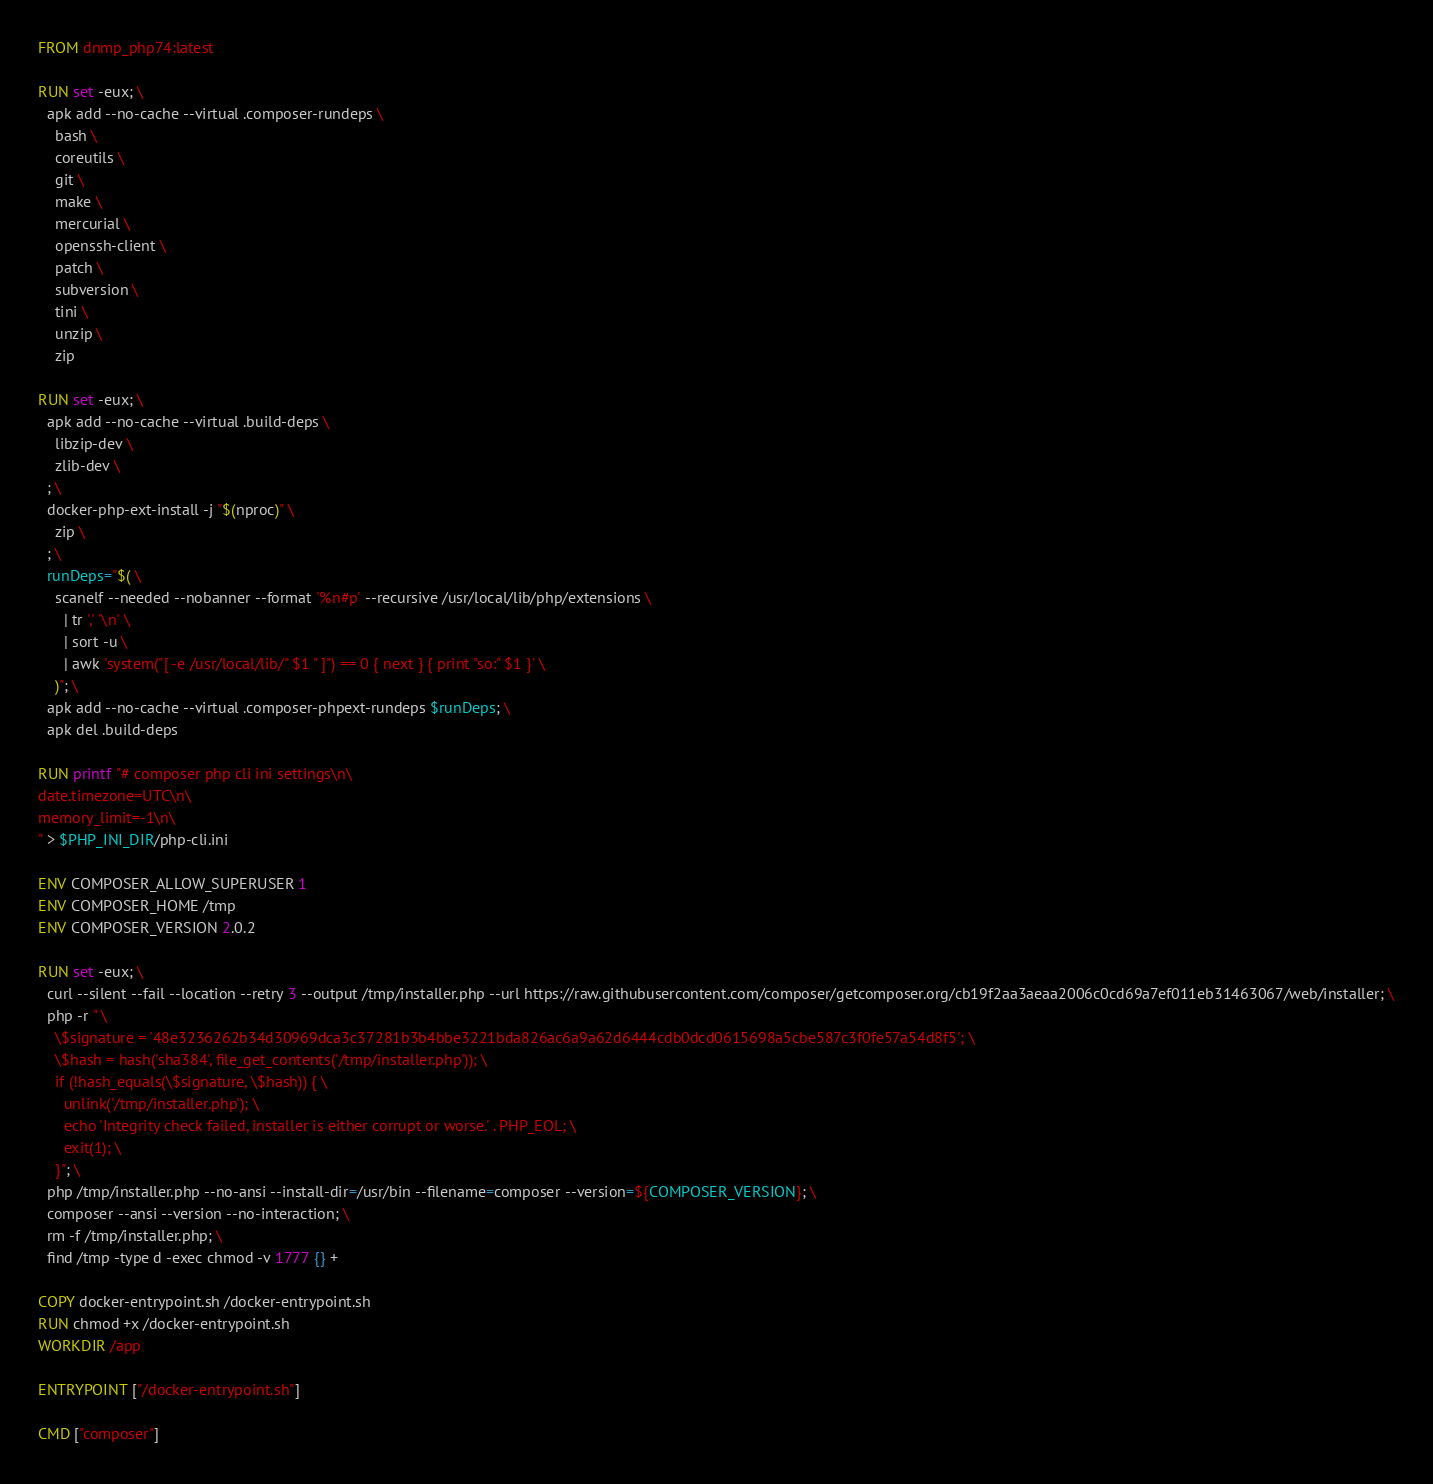<code> <loc_0><loc_0><loc_500><loc_500><_Dockerfile_>FROM dnmp_php74:latest

RUN set -eux; \
  apk add --no-cache --virtual .composer-rundeps \
    bash \
    coreutils \
    git \
    make \
    mercurial \
    openssh-client \
    patch \
    subversion \
    tini \
    unzip \
    zip

RUN set -eux; \
  apk add --no-cache --virtual .build-deps \
    libzip-dev \
    zlib-dev \
  ; \
  docker-php-ext-install -j "$(nproc)" \
    zip \
  ; \
  runDeps="$( \
    scanelf --needed --nobanner --format '%n#p' --recursive /usr/local/lib/php/extensions \
      | tr ',' '\n' \
      | sort -u \
      | awk 'system("[ -e /usr/local/lib/" $1 " ]") == 0 { next } { print "so:" $1 }' \
    )"; \
  apk add --no-cache --virtual .composer-phpext-rundeps $runDeps; \
  apk del .build-deps

RUN printf "# composer php cli ini settings\n\
date.timezone=UTC\n\
memory_limit=-1\n\
" > $PHP_INI_DIR/php-cli.ini

ENV COMPOSER_ALLOW_SUPERUSER 1
ENV COMPOSER_HOME /tmp
ENV COMPOSER_VERSION 2.0.2

RUN set -eux; \
  curl --silent --fail --location --retry 3 --output /tmp/installer.php --url https://raw.githubusercontent.com/composer/getcomposer.org/cb19f2aa3aeaa2006c0cd69a7ef011eb31463067/web/installer; \
  php -r " \
    \$signature = '48e3236262b34d30969dca3c37281b3b4bbe3221bda826ac6a9a62d6444cdb0dcd0615698a5cbe587c3f0fe57a54d8f5'; \
    \$hash = hash('sha384', file_get_contents('/tmp/installer.php')); \
    if (!hash_equals(\$signature, \$hash)) { \
      unlink('/tmp/installer.php'); \
      echo 'Integrity check failed, installer is either corrupt or worse.' . PHP_EOL; \
      exit(1); \
    }"; \
  php /tmp/installer.php --no-ansi --install-dir=/usr/bin --filename=composer --version=${COMPOSER_VERSION}; \
  composer --ansi --version --no-interaction; \
  rm -f /tmp/installer.php; \
  find /tmp -type d -exec chmod -v 1777 {} +

COPY docker-entrypoint.sh /docker-entrypoint.sh
RUN chmod +x /docker-entrypoint.sh
WORKDIR /app

ENTRYPOINT ["/docker-entrypoint.sh"]

CMD ["composer"]</code> 